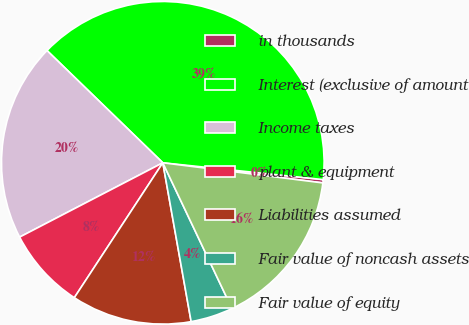<chart> <loc_0><loc_0><loc_500><loc_500><pie_chart><fcel>in thousands<fcel>Interest (exclusive of amount<fcel>Income taxes<fcel>plant & equipment<fcel>Liabilities assumed<fcel>Fair value of noncash assets<fcel>Fair value of equity<nl><fcel>0.33%<fcel>39.41%<fcel>19.87%<fcel>8.14%<fcel>12.05%<fcel>4.24%<fcel>15.96%<nl></chart> 